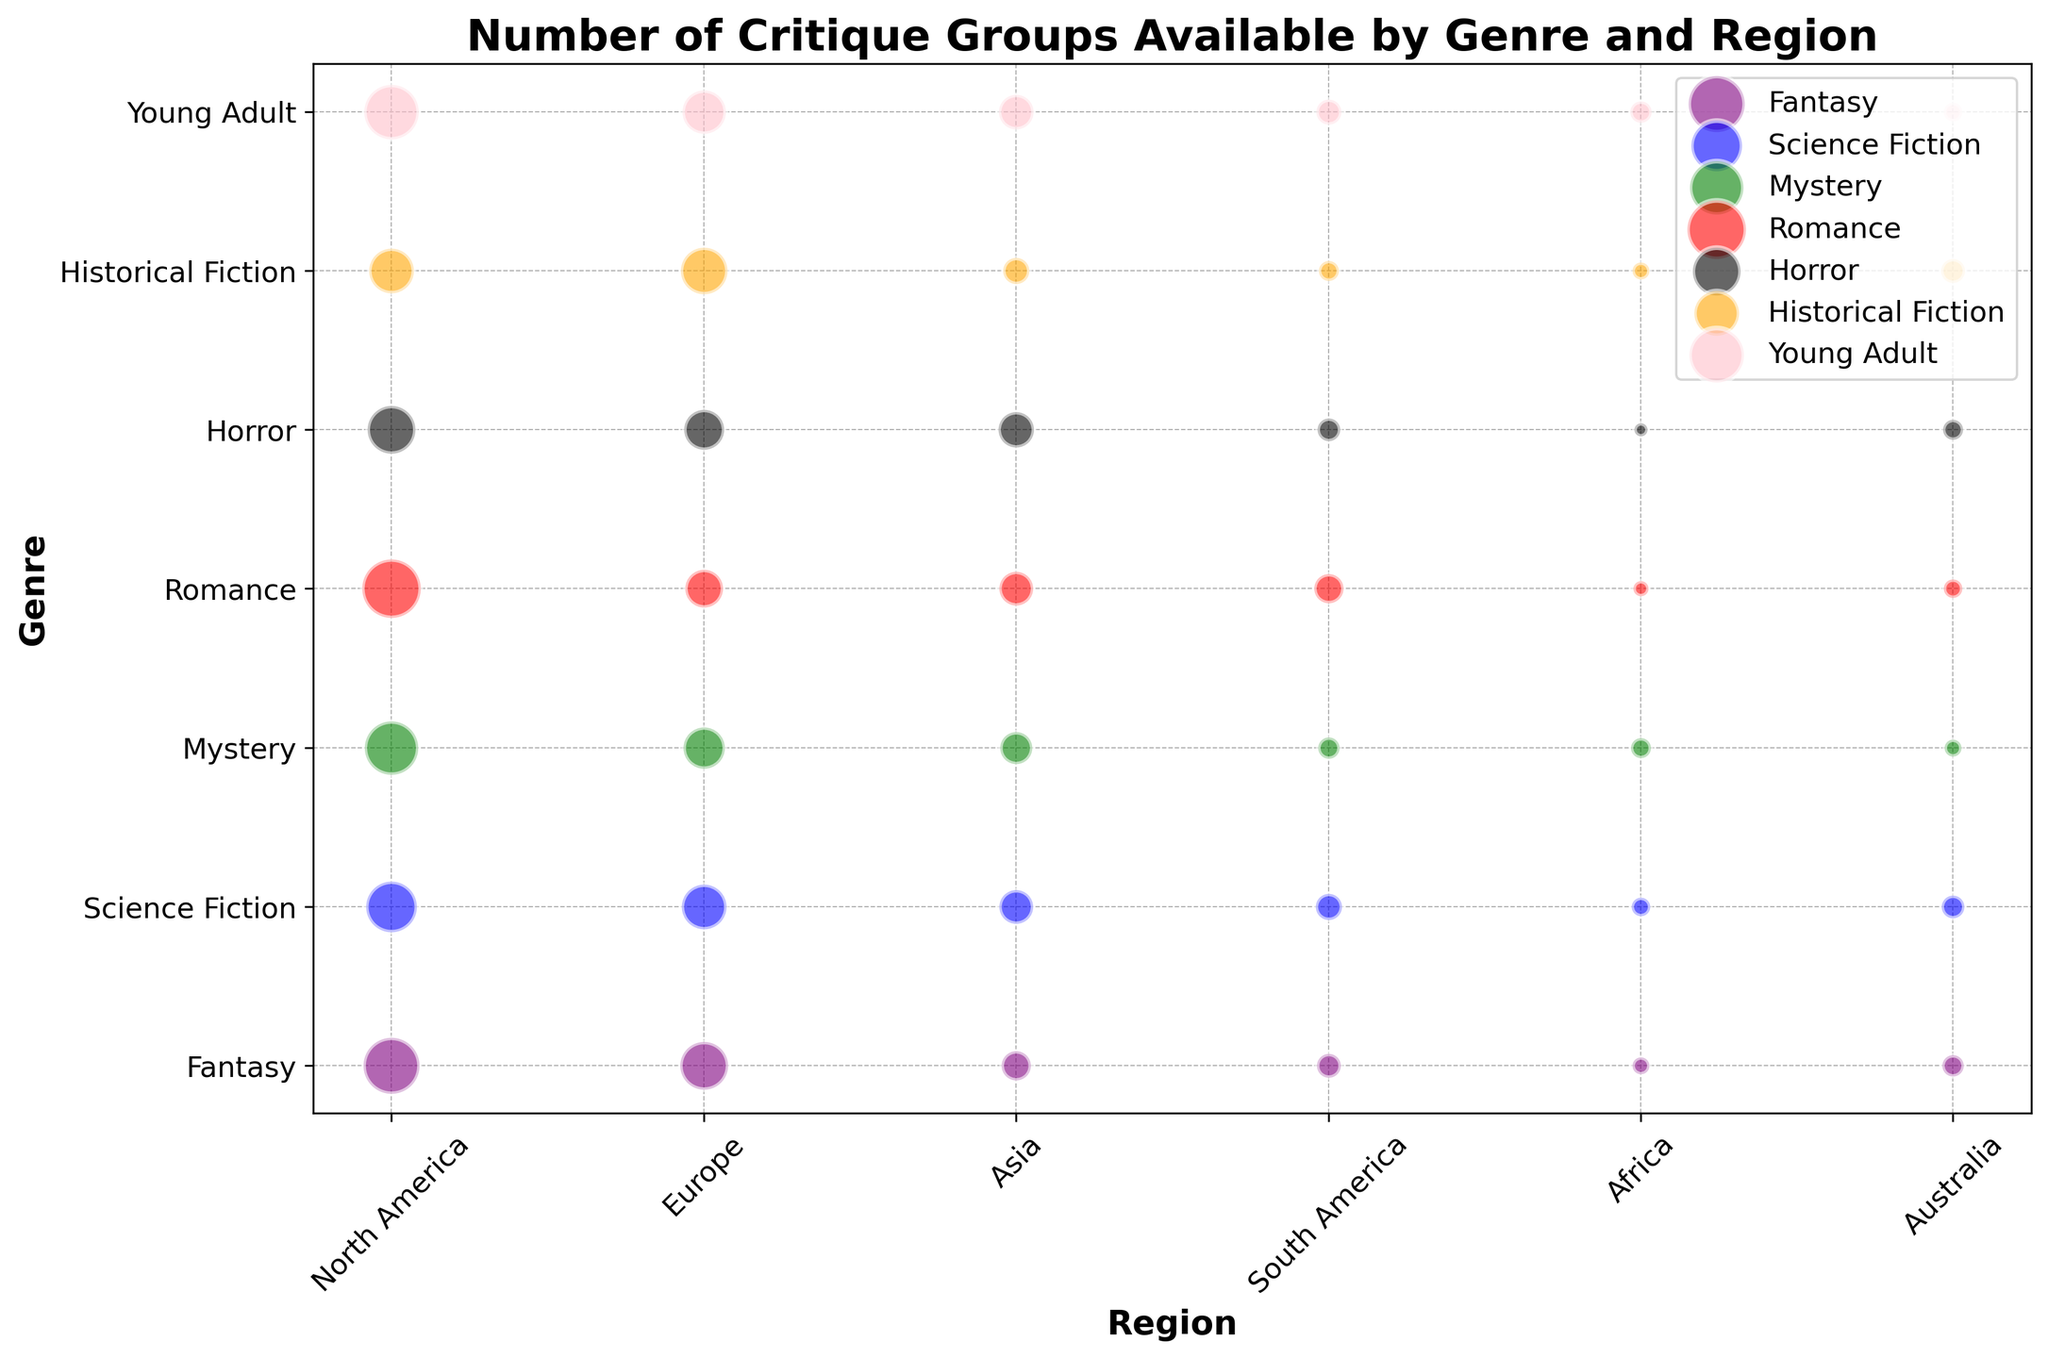What genre has the highest number of critique groups in North America? By looking at the bubbles in North America, the largest bubble corresponds to Romance with 60 critique groups.
Answer: Romance Which region has the fewest critique groups for Horror? By examining the Horror genre bubbles across regions, the smallest bubble is in Africa with 3 critique groups.
Answer: Africa What is the total number of critique groups available for Fantasy across all regions? Summing up the critique groups available for Fantasy in North America (55), Europe (40), Asia (15), South America (10), Africa (5), and Australia (8) results in a total of 133.
Answer: 133 In which genre does Europe have more critique groups than North America? By comparing the bubbles for each genre between Europe and North America, Historical Fiction is the genre with more critique groups in Europe (38) than in North America (35).
Answer: Historical Fiction For which genre is the difference in critique groups between North America and Africa the largest? For each genre, the differences between North America and Africa are calculated as:
- Fantasy: 55 - 5 = 50
- Science Fiction: 45 - 6 = 39
- Mystery: 50 - 7 = 43
- Romance: 60 - 4 = 56
- Horror: 40 - 3 = 37
- Historical Fiction: 35 - 5 = 30
- Young Adult: 52 - 8 = 44
The largest difference is for Romance with a difference of 56.
Answer: Romance Which genre has the most consistent number of critique groups across all regions? To determine consistency, we look for the genre with the smallest difference between the largest and smallest numbers of critique groups across regions:
- Fantasy: 55 - 5 = 50
- Science Fiction: 45 - 6 = 39
- Mystery: 50 - 5 = 45
- Romance: 60 - 4 = 56
- Horror: 40 - 3 = 37
- Historical Fiction: 38 - 5 = 33
- Young Adult: 52 - 6 = 46
Historical Fiction has the most consistent numbers with a range of 33.
Answer: Historical Fiction Which genre in Australia has almost the same number of critique groups as Mystery in Asia? By looking at the sizes of the bubbles, Mystery in Asia has 18 critique groups. In Australia, Science Fiction has 9, Mystery 5, Fantasy 8, Romance 6, Horror 7, Historical Fiction 10, and Young Adult 6. Historical Fiction in Australia with 10 critique groups is the closest.
Answer: Historical Fiction How much larger is the number of Fantasy critique groups in North America than in Asia? The number of Fantasy critique groups in North America is 55, and in Asia, it is 15. The difference is 55 - 15 = 40.
Answer: 40 Which region has the greatest number of critique groups in total for all genres? Summing the critique groups for each region:
- North America: 55 + 45 + 50 + 60 + 40 + 35 + 52 = 337
- Europe: 40 + 35 + 30 + 25 + 28 + 38 + 33 = 229
- Asia: 15 + 20 + 18 + 20 + 22 + 12 + 21 = 128
- South America: 10 + 12 + 8 + 15 + 9 + 7 + 11 = 72
- Africa: 5 + 6 + 7 + 4 + 3 + 5 + 8 = 38
- Australia: 8 + 9 + 5 + 6 + 7 + 10 + 6 = 51
North America has the greatest number of critique groups with 337.
Answer: North America 